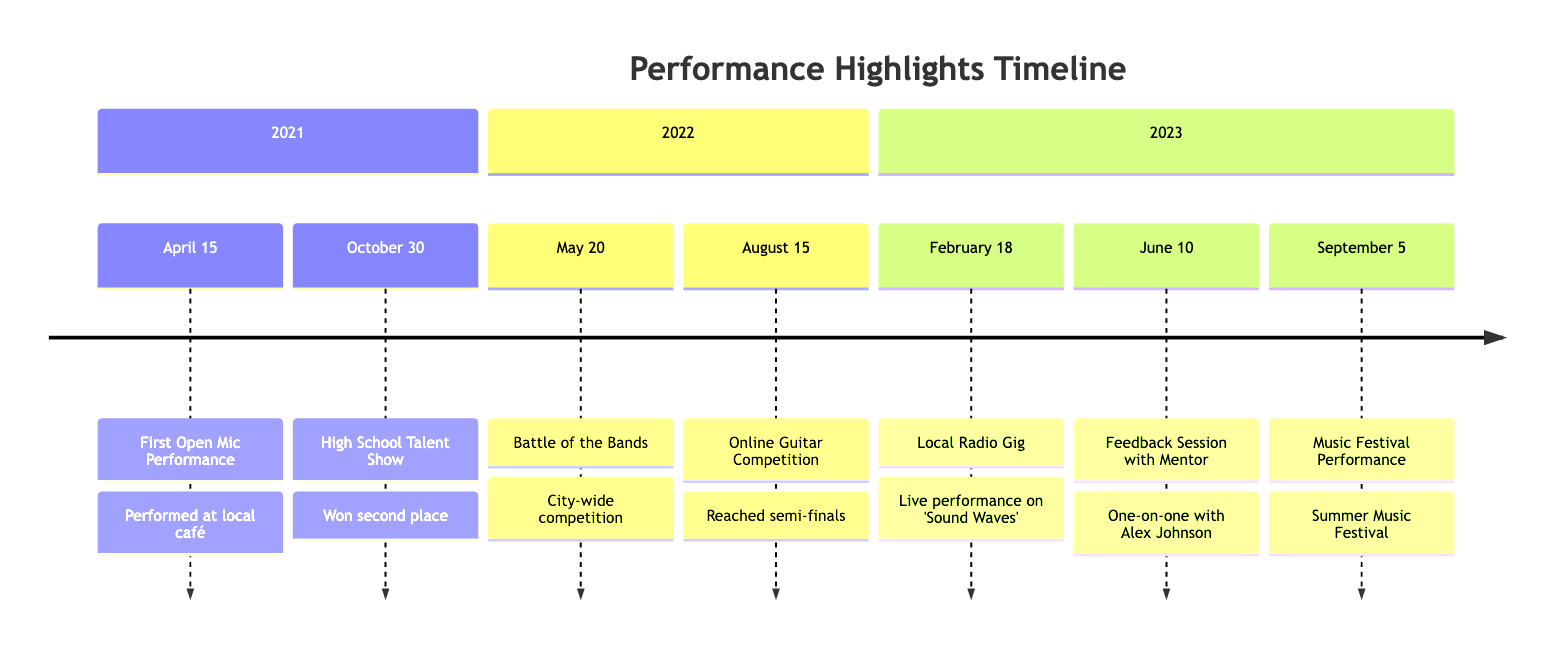What was the first performance highlight? The first performance highlight listed is the "First Open Mic Performance" which took place on April 15, 2021.
Answer: First Open Mic Performance How many competitions are mentioned in the timeline? The timeline lists three competitions: "Battle of the Bands," "Online Guitar Competition," and "High School Talent Show."
Answer: 3 What feedback received on February 18, 2023? On this date, the feedback given was that the performance on the community radio show "Sound Waves" was praised for technical skills and emotive playing.
Answer: Praised for technical skills and emotive playing Which performance received second place? The "High School Talent Show" on October 30, 2021, awarded second place to the participant.
Answer: Second place When was the feedback session with the mentor held? The feedback session with mentor Alex Johnson occurred on June 10, 2023.
Answer: June 10, 2023 Which event had the most recent date? The "Music Festival Performance," which took place on September 5, 2023, is the most recent event in the timeline.
Answer: Music Festival Performance What type of venue was the first performance held at? The first performance was held at a local café called "The Coffeehouse Sessions."
Answer: Local café Which performance was noted for original composition? The "Battle of the Bands" on May 20, 2022, was noted for the original composition and energetic performance.
Answer: Battle of the Bands 